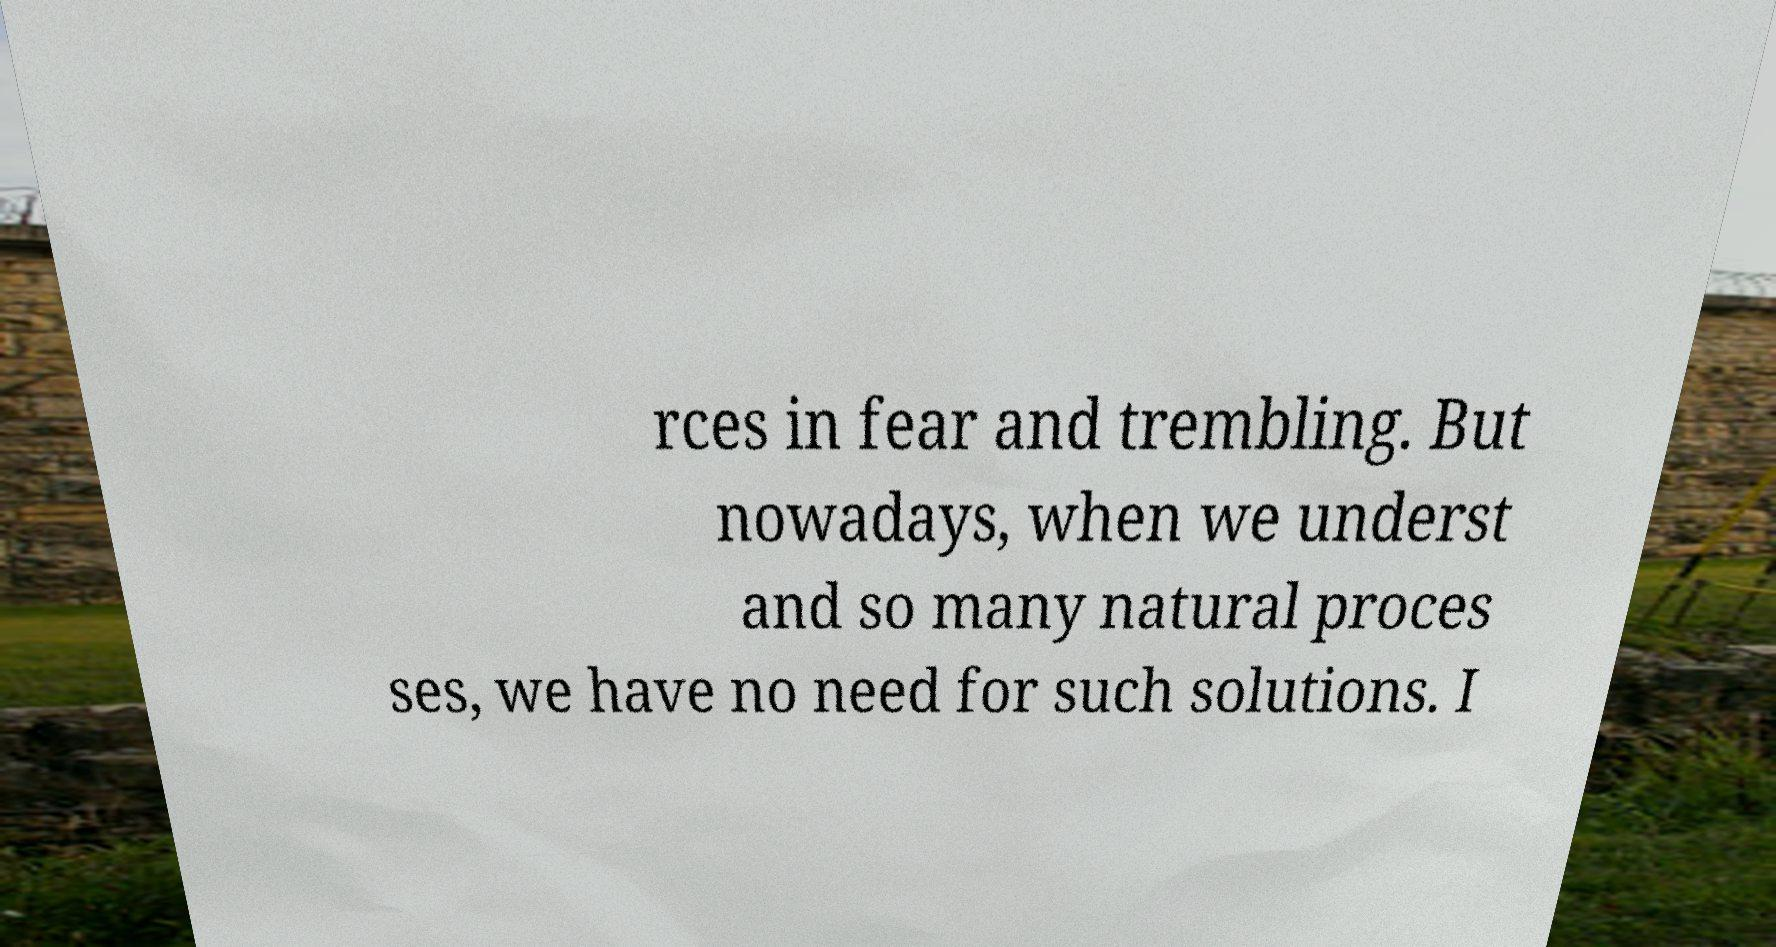For documentation purposes, I need the text within this image transcribed. Could you provide that? rces in fear and trembling. But nowadays, when we underst and so many natural proces ses, we have no need for such solutions. I 